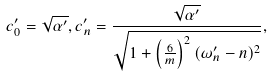<formula> <loc_0><loc_0><loc_500><loc_500>c _ { 0 } ^ { \prime } = \sqrt { \alpha ^ { \prime } } , c _ { n } ^ { \prime } = \frac { \sqrt { \alpha ^ { \prime } } } { \sqrt { 1 + \left ( \frac { 6 } { m } \right ) ^ { 2 } ( \omega _ { n } ^ { \prime } - n ) ^ { 2 } } } ,</formula> 